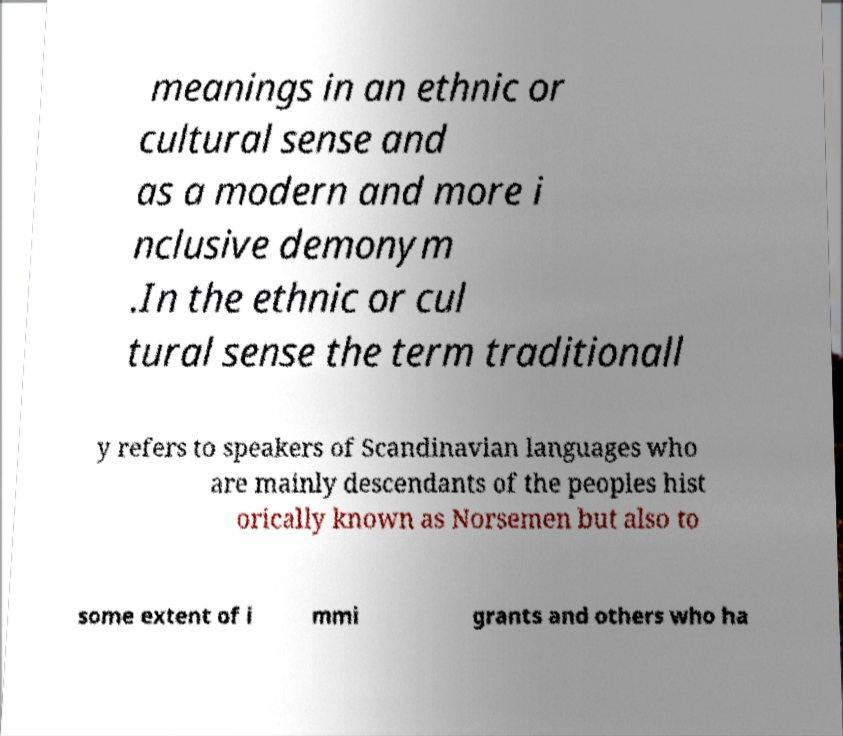Please read and relay the text visible in this image. What does it say? meanings in an ethnic or cultural sense and as a modern and more i nclusive demonym .In the ethnic or cul tural sense the term traditionall y refers to speakers of Scandinavian languages who are mainly descendants of the peoples hist orically known as Norsemen but also to some extent of i mmi grants and others who ha 